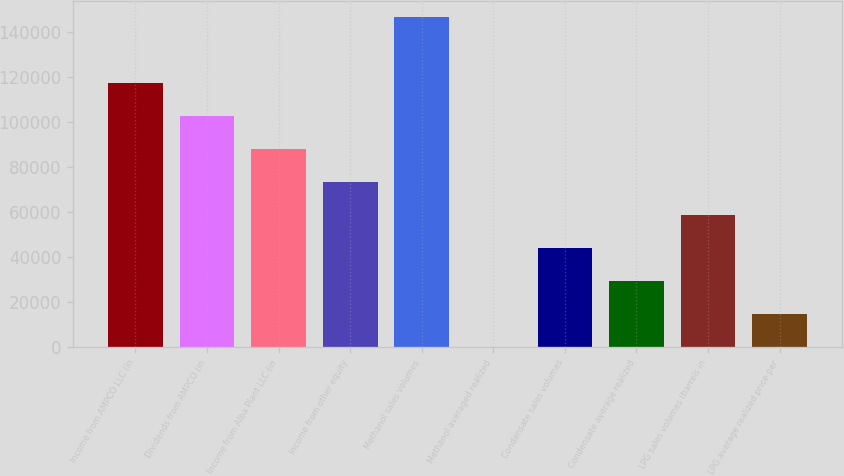<chart> <loc_0><loc_0><loc_500><loc_500><bar_chart><fcel>Income from AMPCO LLC (in<fcel>Dividends from AMPCO (in<fcel>Income from Alba Plant LLC (in<fcel>Income from other equity<fcel>Methanol sales volumes<fcel>Methanol averaged realized<fcel>Condensate sales volumes<fcel>Condensate average realized<fcel>LPG sales volumes (barrels in<fcel>LPG average realized price per<nl><fcel>117457<fcel>102775<fcel>88092.9<fcel>73410.8<fcel>146821<fcel>0.69<fcel>44046.8<fcel>29364.8<fcel>58728.8<fcel>14682.7<nl></chart> 